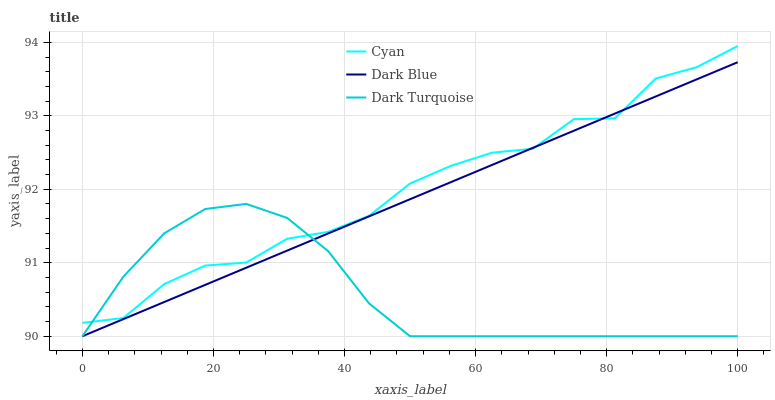Does Dark Turquoise have the minimum area under the curve?
Answer yes or no. Yes. Does Cyan have the maximum area under the curve?
Answer yes or no. Yes. Does Dark Blue have the minimum area under the curve?
Answer yes or no. No. Does Dark Blue have the maximum area under the curve?
Answer yes or no. No. Is Dark Blue the smoothest?
Answer yes or no. Yes. Is Cyan the roughest?
Answer yes or no. Yes. Is Dark Turquoise the smoothest?
Answer yes or no. No. Is Dark Turquoise the roughest?
Answer yes or no. No. Does Cyan have the highest value?
Answer yes or no. Yes. Does Dark Blue have the highest value?
Answer yes or no. No. 